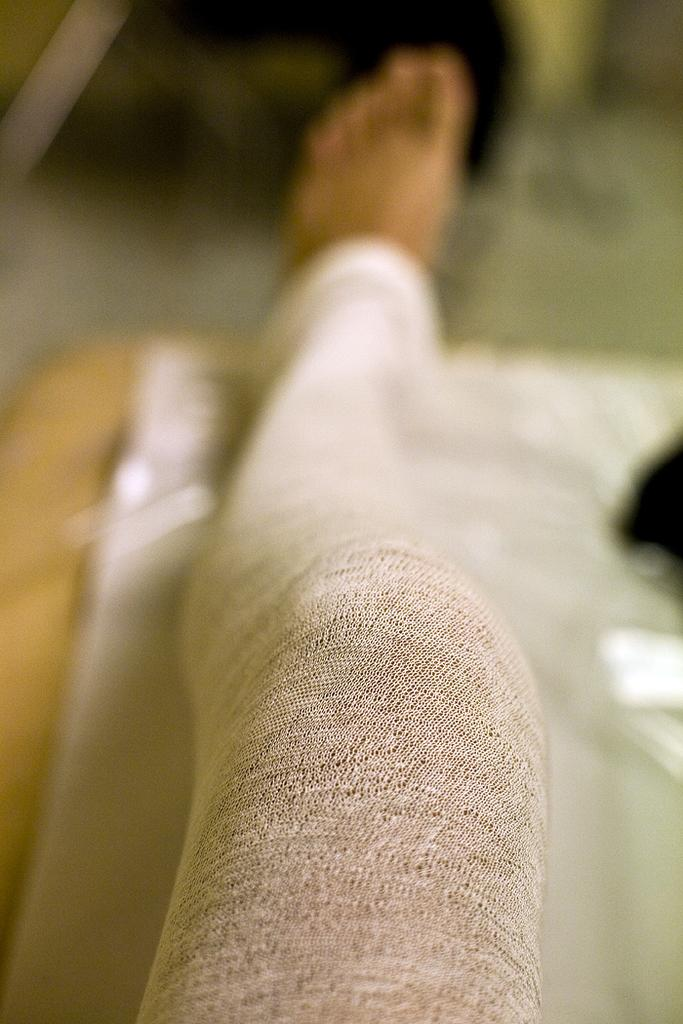What part of a person's body is visible in the image? There is a person's leg in the image. What color are the pants that the leg is wearing? The person's leg is wearing white-colored pants. On what surface is the leg placed? The leg is placed on a surface. Can you describe the background of the image? The background of the image is blurred. What type of behavior can be observed in the ducks in the image? There are no ducks present in the image, so no behavior can be observed. 